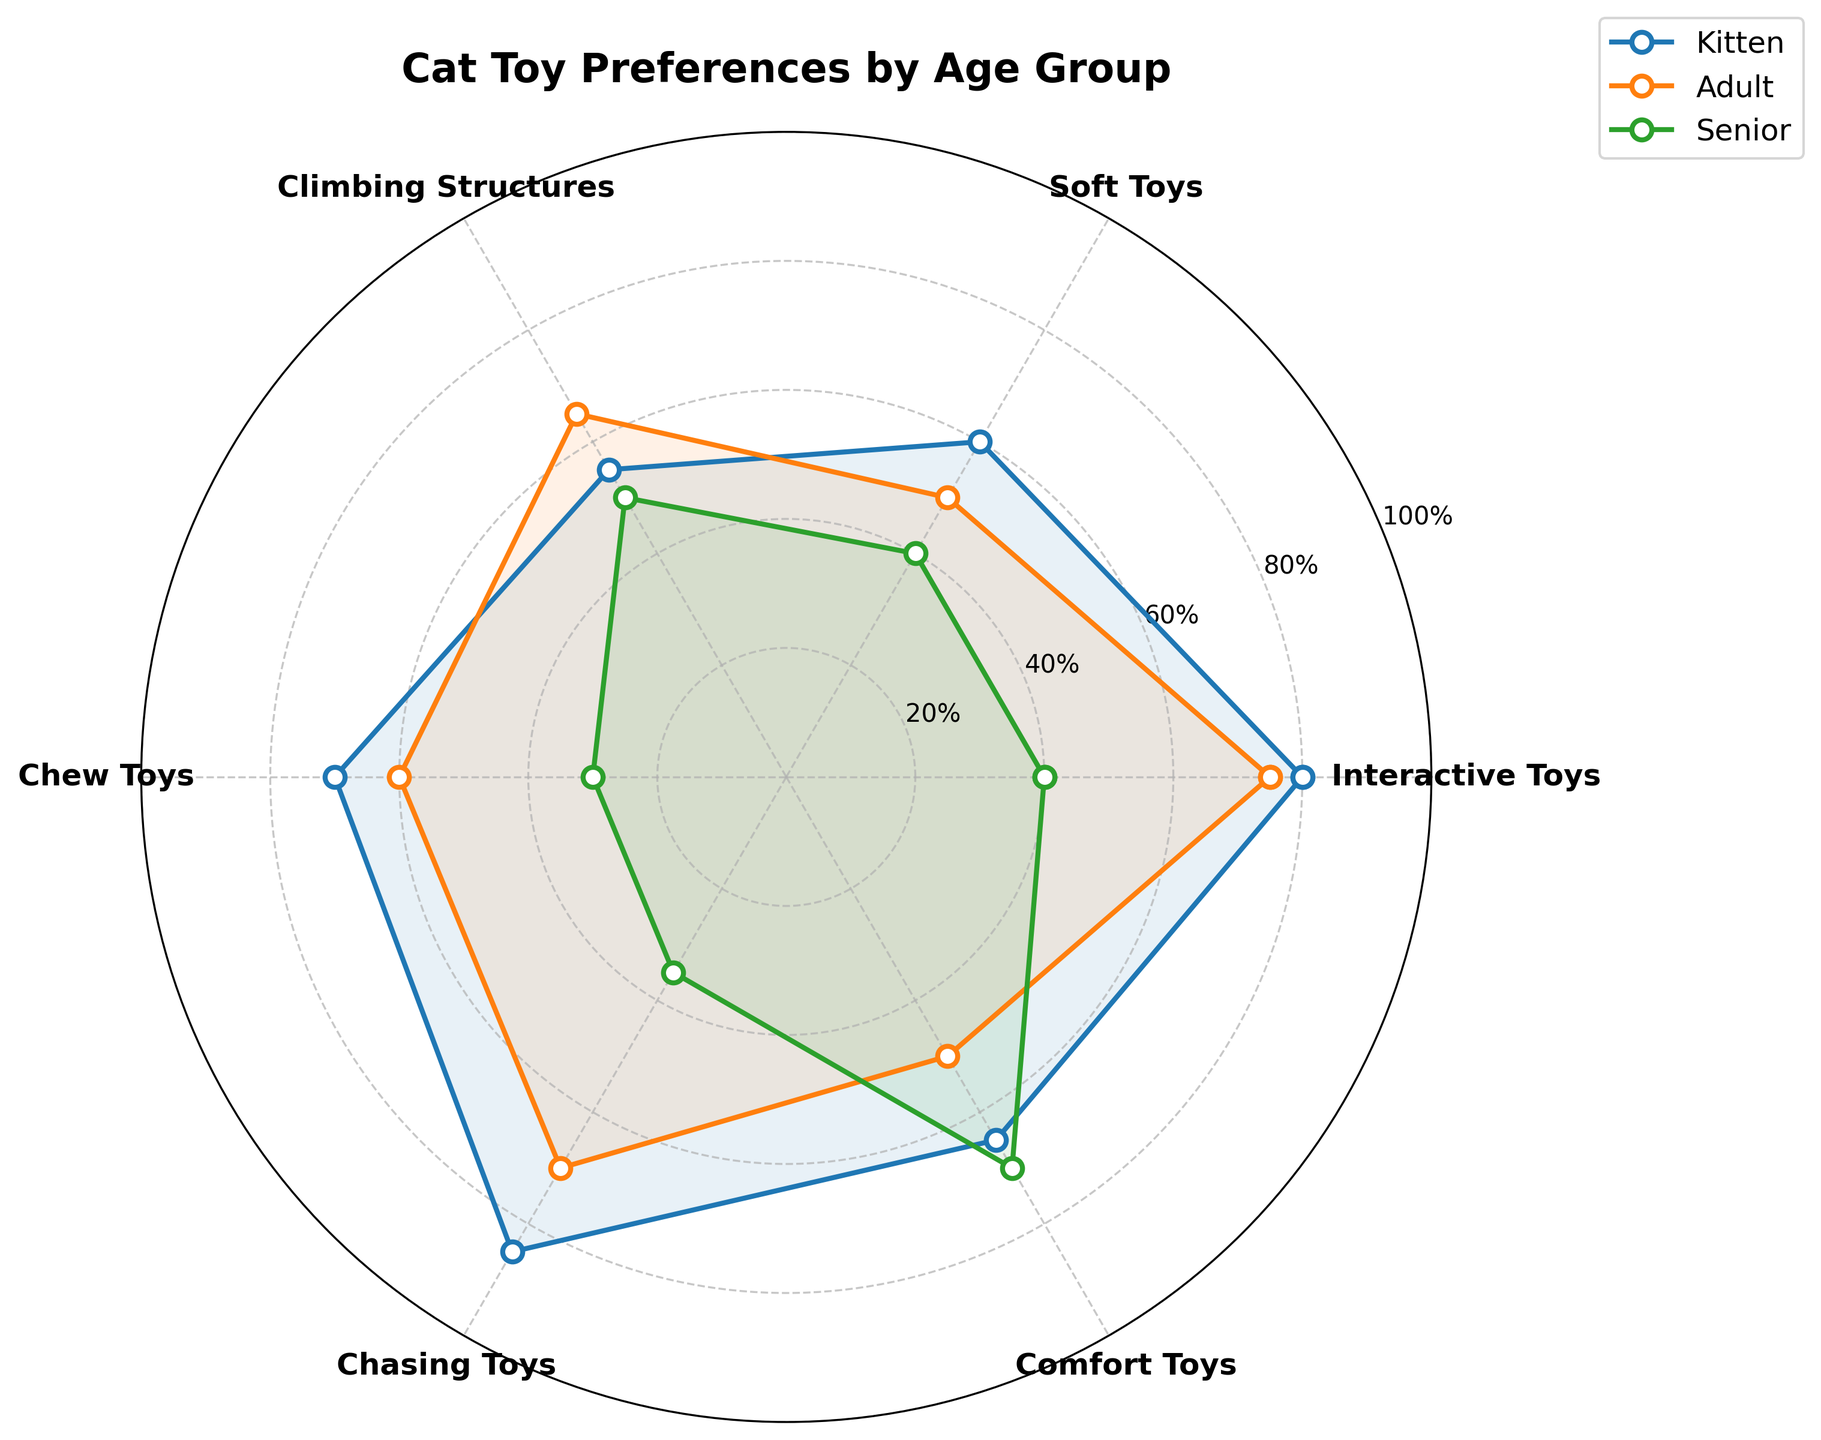Which age group has the highest preference for chasing toys? To determine the group with the highest preference for chasing toys, we compare the values for each group. For kittens, the value is 85, for adults it is 70, and for seniors it is 35. Thus, kittens have the highest preference for chasing toys.
Answer: Kittens What is the difference in preference for soft toys between kittens and seniors? The preference value for soft toys in kittens is 60 and for seniors is 40. The difference is calculated by subtracting the senior value from the kitten value: 60 - 40 = 20.
Answer: 20 How does the preference for comfort toys change from kittens to seniors? The preference value for comfort toys is 65 for kittens, 50 for adults, and 70 for seniors. There is a decrease from kittens to adults by 15 (65 - 50), and an increase from adults to seniors by 20 (70 - 50). Overall, comparing directly from kittens to seniors, there's an increase of 5 (70 - 65).
Answer: Increase by 5 Which age group has the least preference for chew toys? By looking at the values for chew toys, we have 70 for kittens, 60 for adults, and 30 for seniors. So seniors have the least preference for chew toys.
Answer: Seniors Are climbing structures more preferred by kittens or adults? The value for climbing structures is 55 for kittens and 65 for adults. Since 65 is greater than 55, adults prefer climbing structures more than kittens do.
Answer: Adults What's the sum of the preference values for interactive and chasing toys for adults? For adults, the value for interactive toys is 75 and for chasing toys it is 70. Adding these together: 75 + 70 = 145.
Answer: 145 What is the average preference for all toy types for seniors? Add the values for all toy types for seniors: 40 + 40 + 50 + 30 + 35 + 70 = 265. Then, divide by the number of toy types (6): 265 / 6 ≈ 44.2.
Answer: 44.2 Is the preference for interactive toys greater in kittens or adults? The value for interactive toys is 80 for kittens and 75 for adults. Since 80 is greater than 75, kittens have a higher preference.
Answer: Kittens 